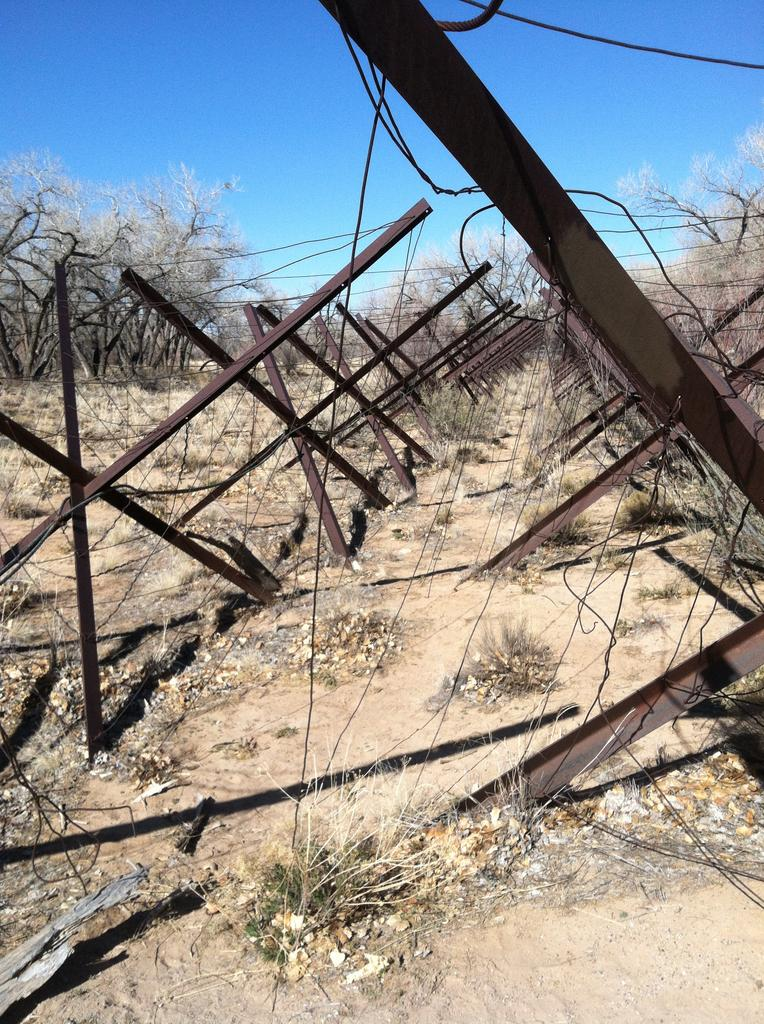What type of objects are made of metal in the image? The metal objects in the image are not specified, but they can be identified by their appearance. What is connected by the electric wires in the image? The purpose or destination of the electric wires in the image is not mentioned, but they are likely connected to some electrical devices or systems. What type of vegetation is present in the image? Trees are the type of vegetation present in the image. What can be seen in the sky in the image? Clouds are present in the sky in the image. How many houses are visible in the image? There are no houses mentioned or visible in the image. What color is the bubble floating in the image? There is no bubble present in the image. 